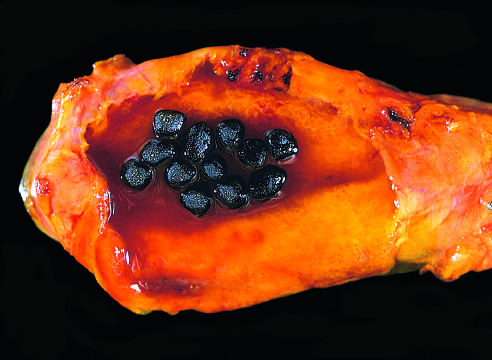what are present in this otherwise unremarkable gallbladder from a patient with a mechanical mitral valve prosthesis, leading to chronic intravascular hemolysis?
Answer the question using a single word or phrase. Several faceted black gallstones 